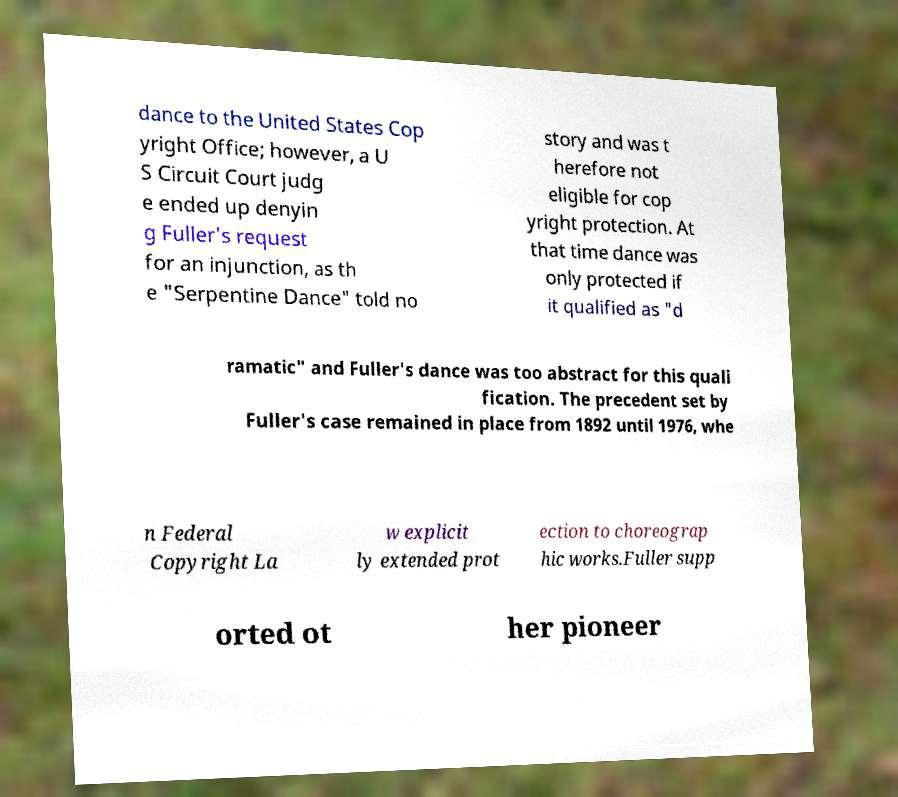For documentation purposes, I need the text within this image transcribed. Could you provide that? dance to the United States Cop yright Office; however, a U S Circuit Court judg e ended up denyin g Fuller's request for an injunction, as th e "Serpentine Dance" told no story and was t herefore not eligible for cop yright protection. At that time dance was only protected if it qualified as "d ramatic" and Fuller's dance was too abstract for this quali fication. The precedent set by Fuller's case remained in place from 1892 until 1976, whe n Federal Copyright La w explicit ly extended prot ection to choreograp hic works.Fuller supp orted ot her pioneer 